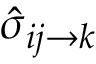Convert formula to latex. <formula><loc_0><loc_0><loc_500><loc_500>{ \hat { \sigma } } _ { i j \rightarrow k }</formula> 